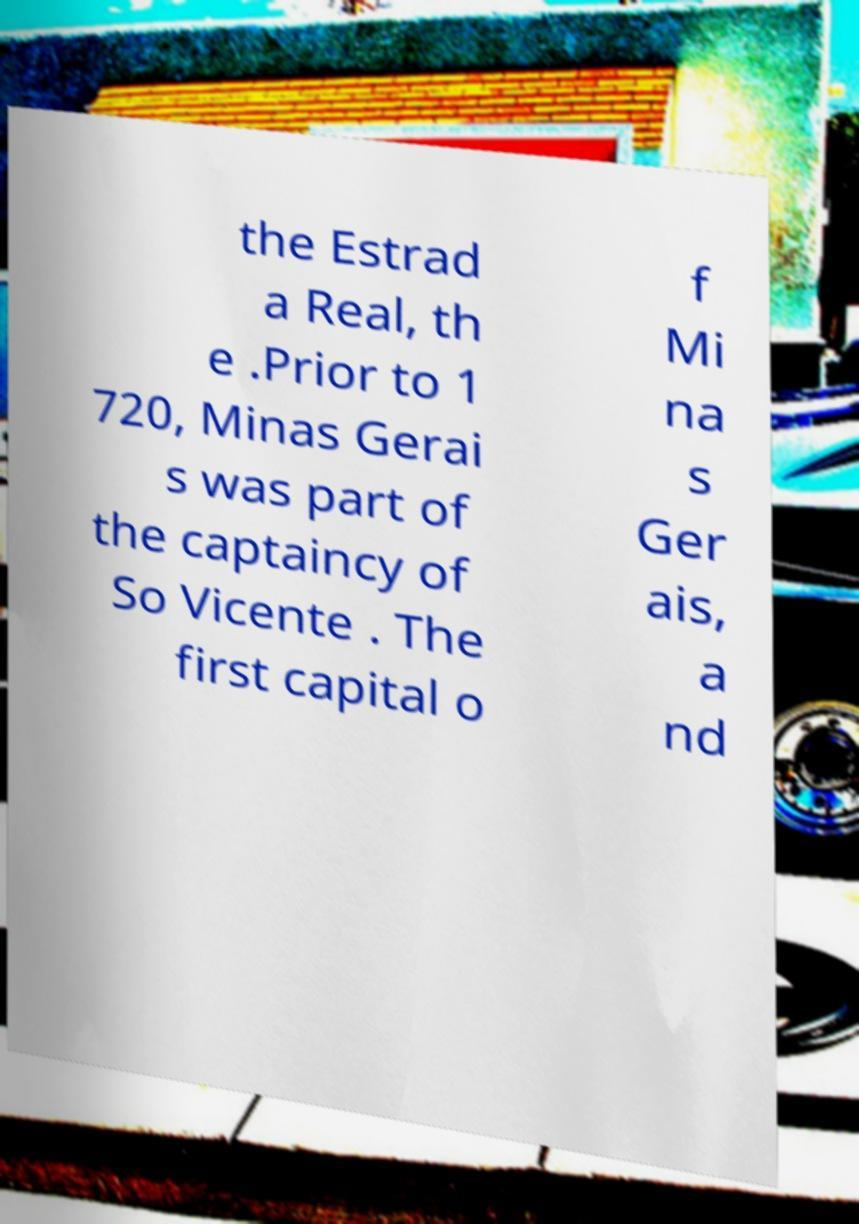For documentation purposes, I need the text within this image transcribed. Could you provide that? the Estrad a Real, th e .Prior to 1 720, Minas Gerai s was part of the captaincy of So Vicente . The first capital o f Mi na s Ger ais, a nd 